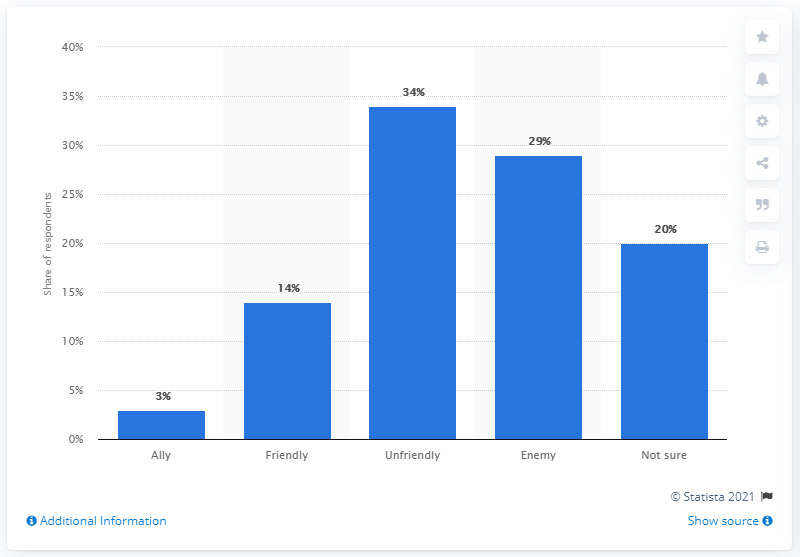List a handful of essential elements in this visual. According to a recent survey, a significant percentage of Americans view Russia as an ally of the United States. Specifically, 3% of respondents answered in the affirmative. 